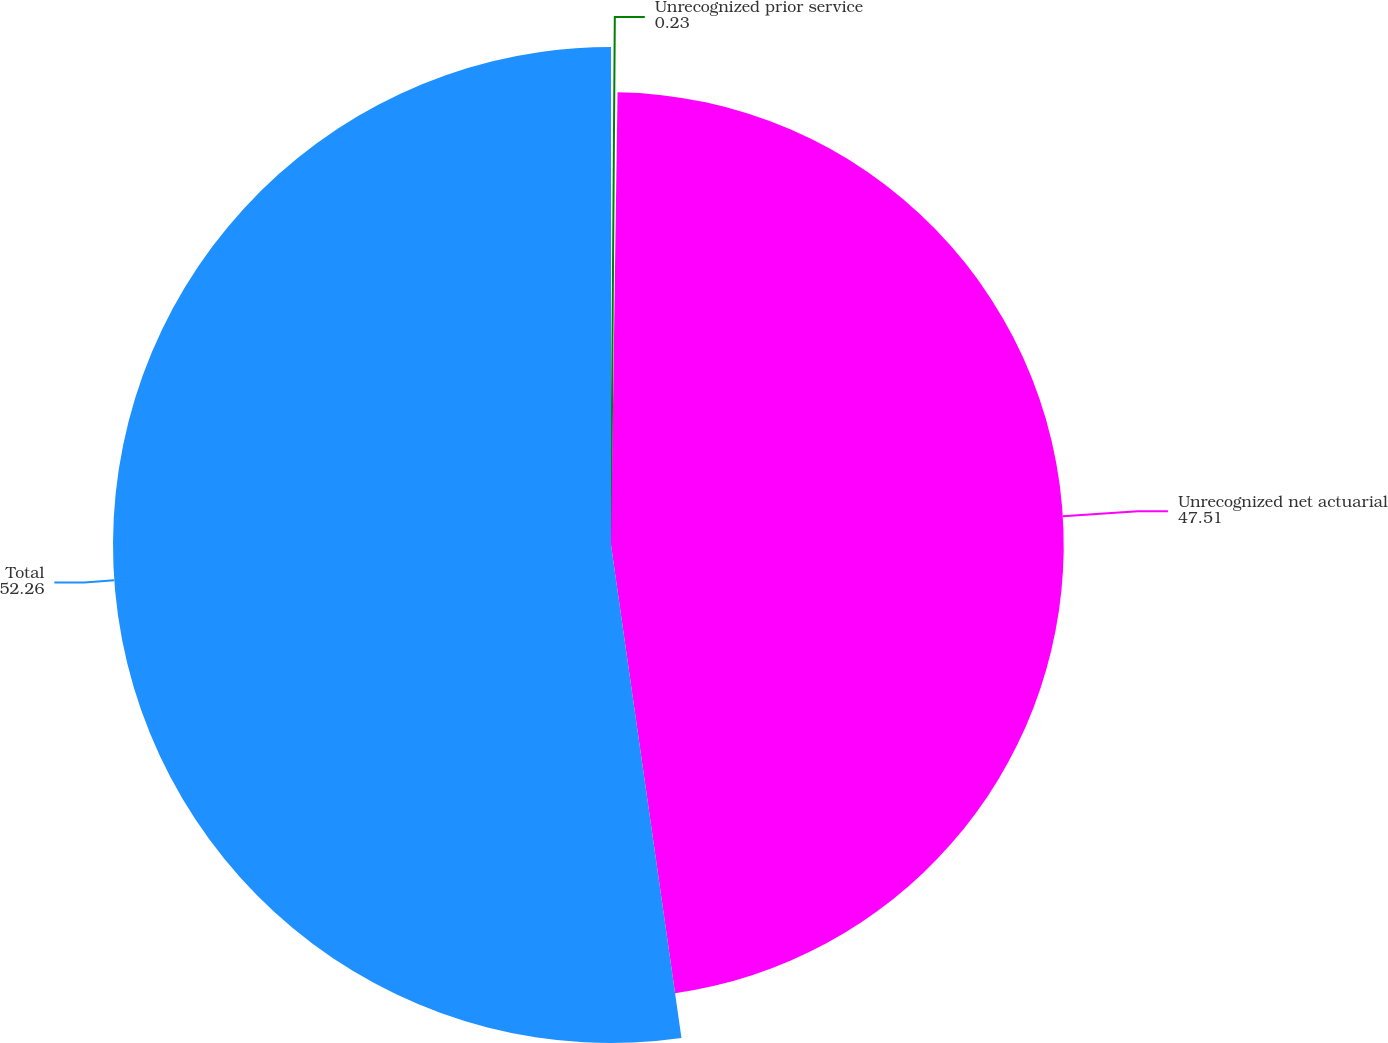Convert chart. <chart><loc_0><loc_0><loc_500><loc_500><pie_chart><fcel>Unrecognized prior service<fcel>Unrecognized net actuarial<fcel>Total<nl><fcel>0.23%<fcel>47.51%<fcel>52.26%<nl></chart> 